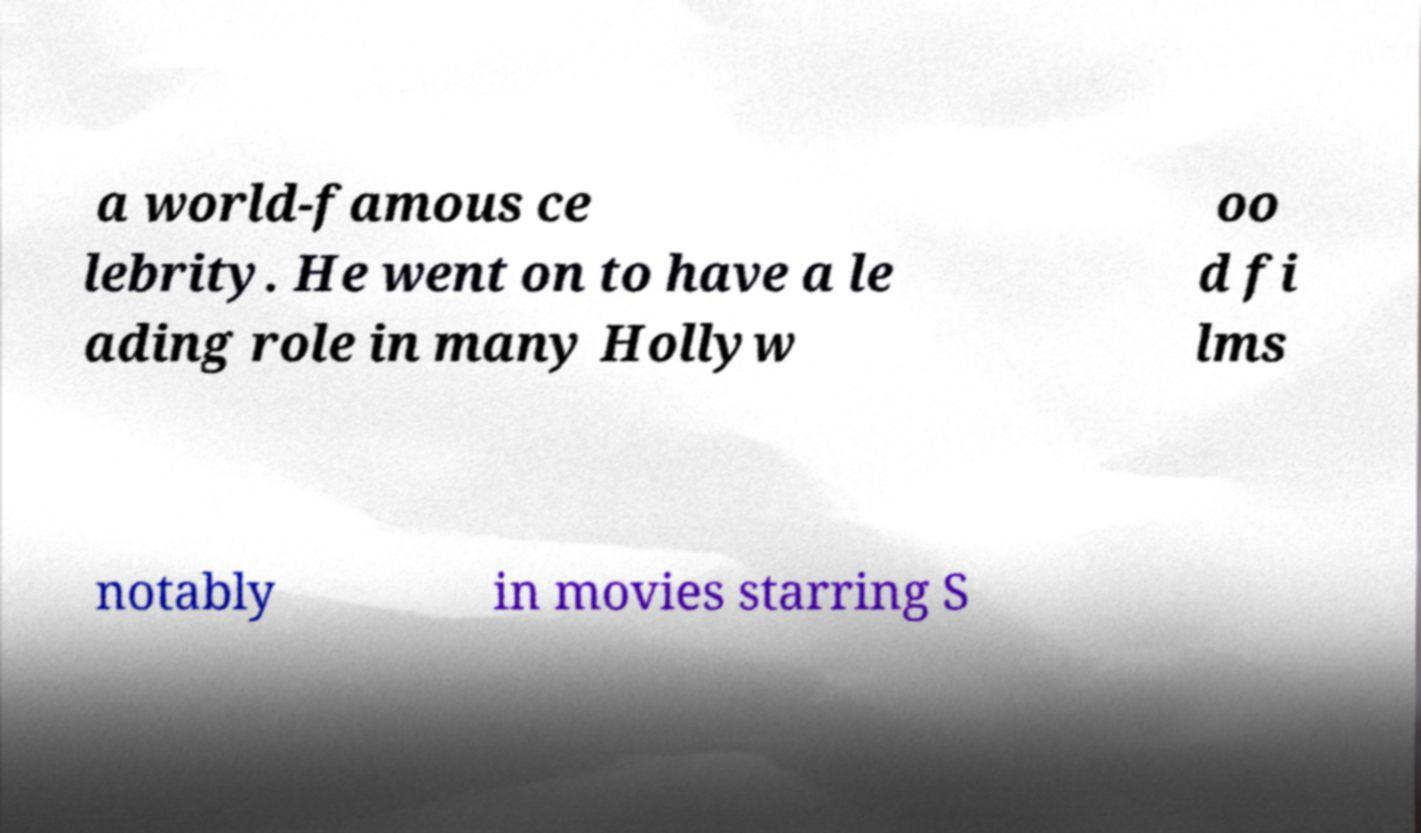Can you read and provide the text displayed in the image?This photo seems to have some interesting text. Can you extract and type it out for me? a world-famous ce lebrity. He went on to have a le ading role in many Hollyw oo d fi lms notably in movies starring S 